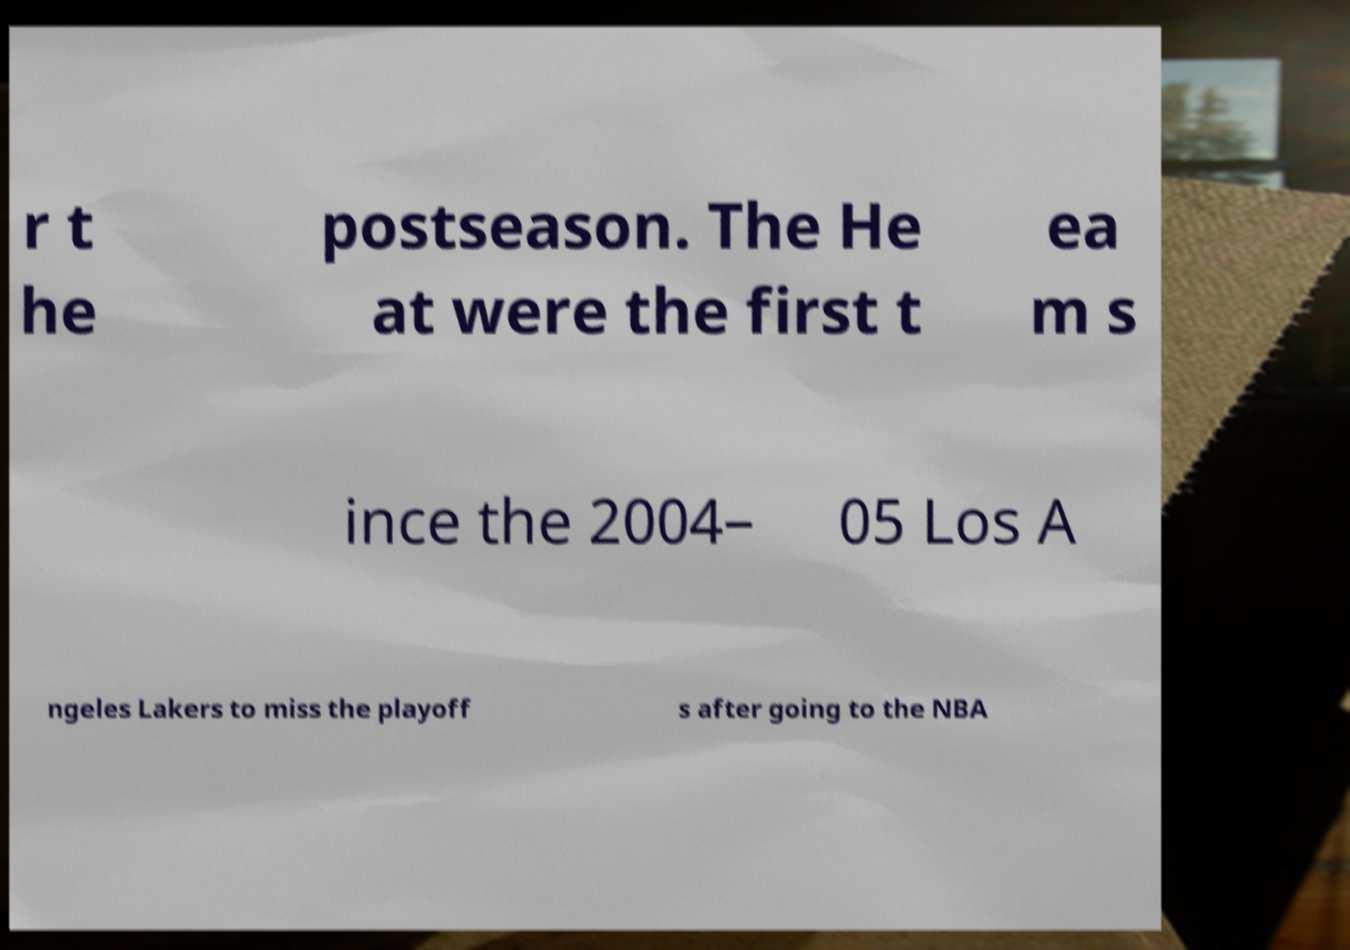What messages or text are displayed in this image? I need them in a readable, typed format. r t he postseason. The He at were the first t ea m s ince the 2004– 05 Los A ngeles Lakers to miss the playoff s after going to the NBA 